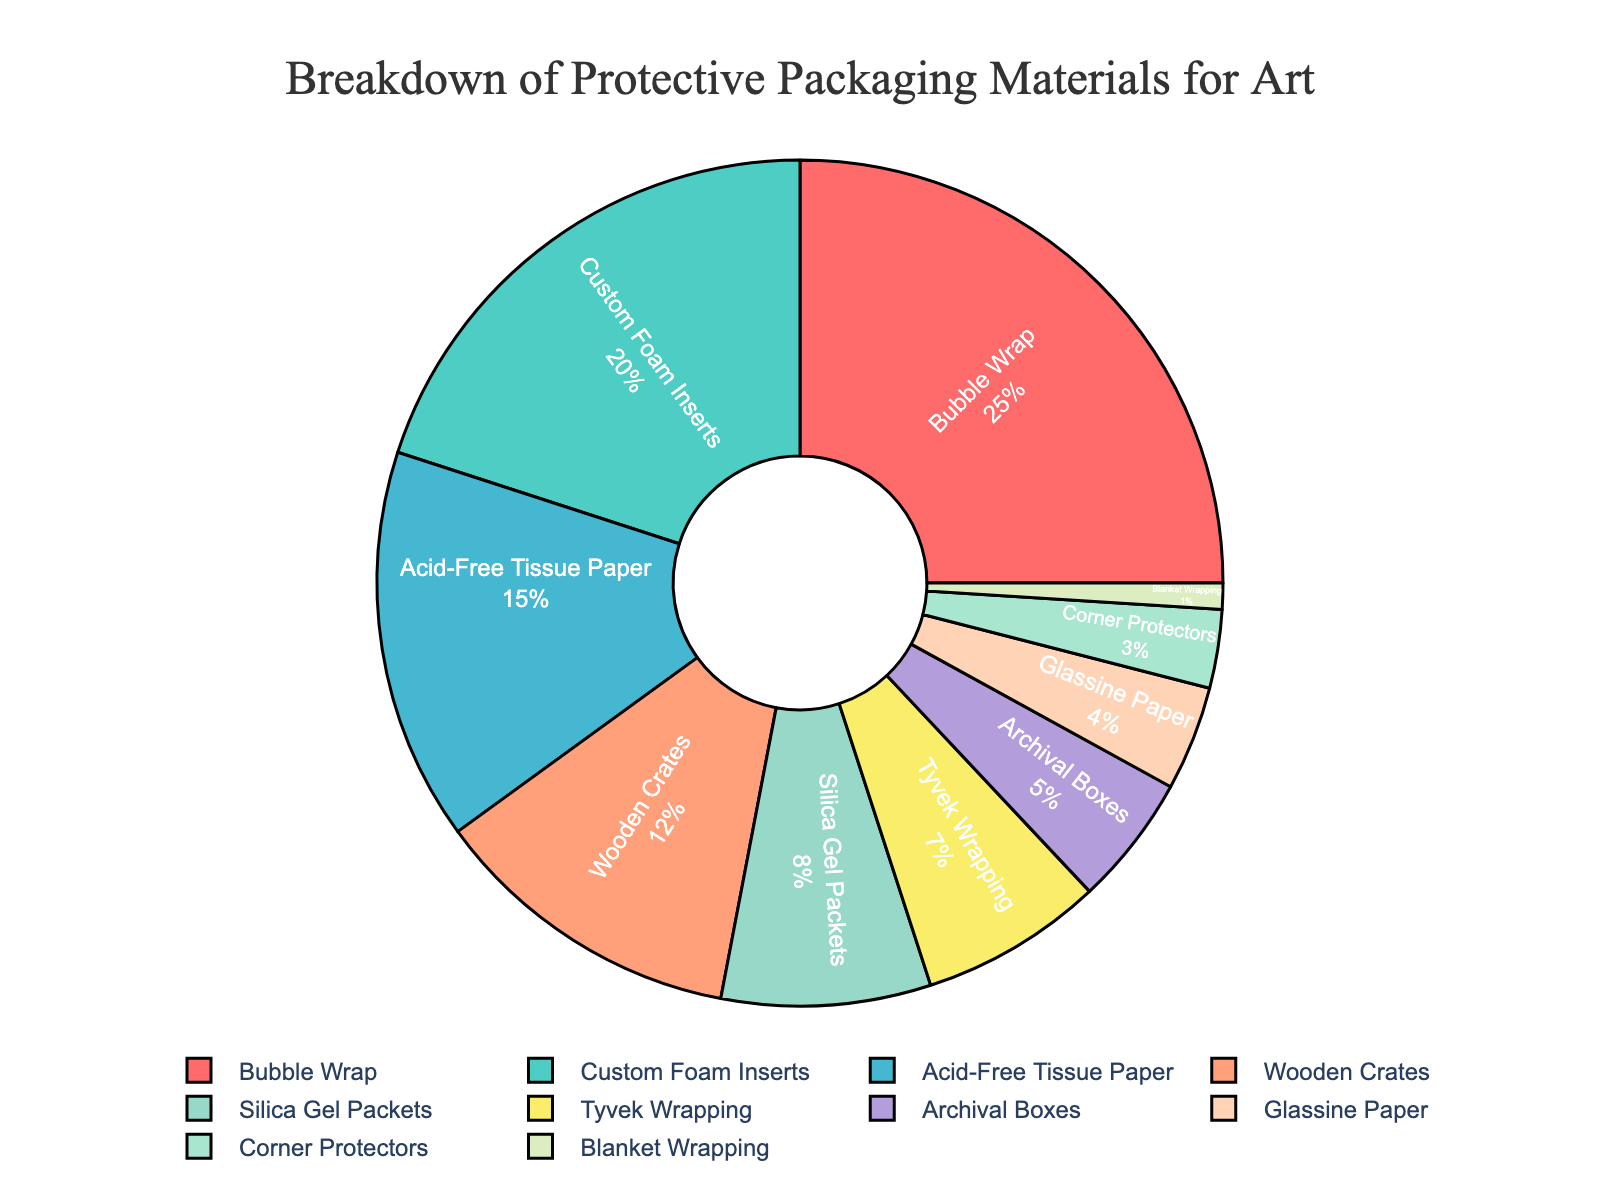Which packaging material is used the most for art? By looking at the pie chart, Bubble Wrap has the largest segment.
Answer: Bubble Wrap What percentage of the materials used are Custom Foam Inserts? The pie chart shows each segment's percentage, and Custom Foam Inserts make up 20% of the total.
Answer: 20% Which two materials combined make up less than 10% of the total packaging materials? The materials Tyvek Wrapping (7%) and Blanket Wrapping (1%) together make up 8%, which is less than 10%.
Answer: Tyvek Wrapping and Blanket Wrapping Which material has a higher usage percentage: Wooden Crates or Glassine Paper? By comparing the two segments in the pie chart, Wooden Crates (12%) have a higher percentage than Glassine Paper (4%).
Answer: Wooden Crates What is the combined percentage of Acid-Free Tissue Paper and Archival Boxes? Acid-Free Tissue Paper is 15% and Archival Boxes are 5%, their sum is 15% + 5% = 20%.
Answer: 20% How much more is the percentage of Bubble Wrap compared to Silica Gel Packets? Bubble Wrap is 25% and Silica Gel Packets are 8%, the difference is 25% - 8% = 17%.
Answer: 17% What's the difference in combined percentage between the two least used and the two most-used materials? Bubble Wrap (25%) + Custom Foam Inserts (20%) = 45%, and Blanket Wrapping (1%) + Corner Protectors (3%) = 4%, the difference is 45% - 4% = 41%.
Answer: 41% Which materials are represented by green tones in the pie chart? The color associated with Wooden Crates and Glassine Paper is green as indicated by their segments in the pie chart.
Answer: Wooden Crates and Glassine Paper 